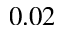Convert formula to latex. <formula><loc_0><loc_0><loc_500><loc_500>0 . 0 2</formula> 